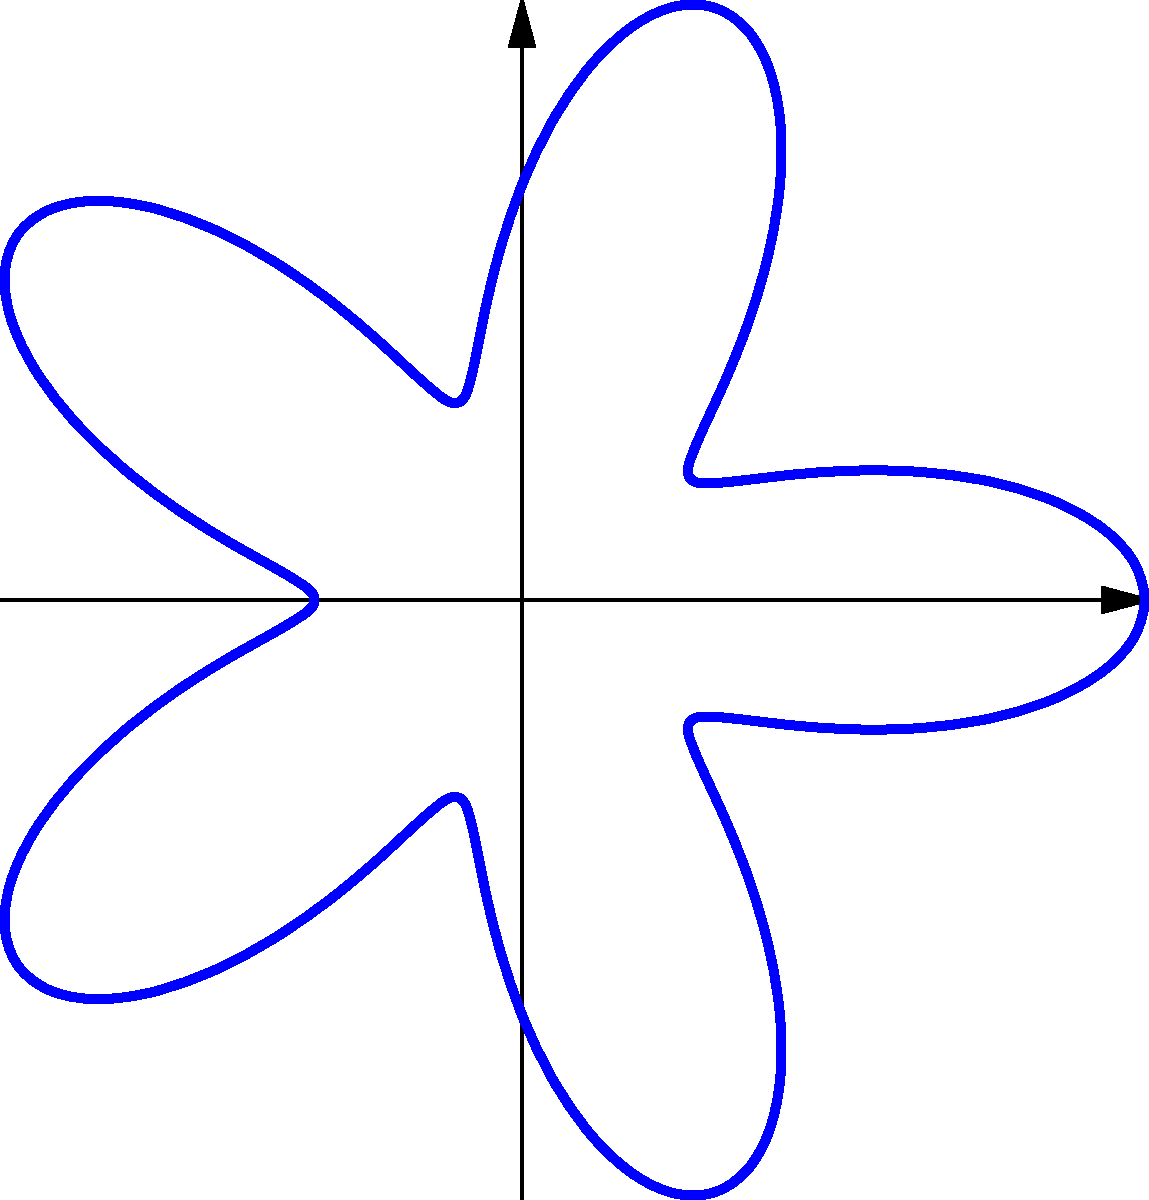For a star-shaped party favor, you're using the polar equation $r = 2 + \cos(5\theta)$. How many points does this star have? To determine the number of points in the star, we need to follow these steps:

1) In polar equations, a complete revolution is $2\pi$ radians.

2) The frequency of the cosine function in the equation is 5, as seen in $\cos(5\theta)$.

3) This means the pattern repeats 5 times in one complete revolution.

4) Each repetition creates one point of the star.

5) Therefore, the number of points in the star is equal to the frequency of the cosine function.
Answer: 5 points 